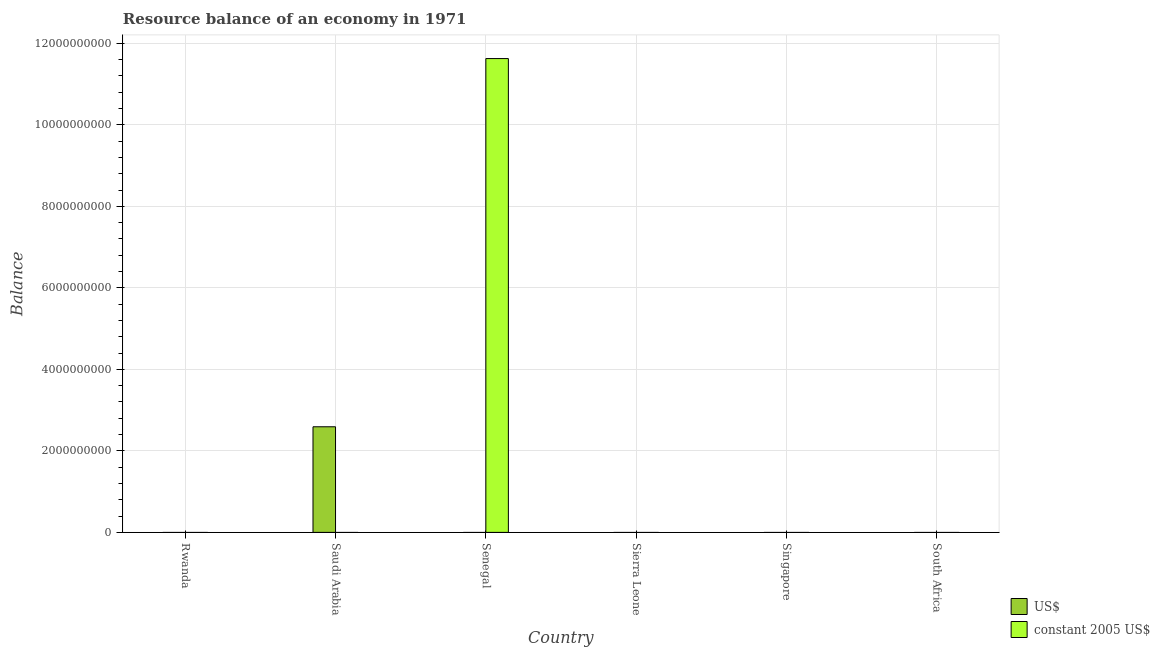How many different coloured bars are there?
Ensure brevity in your answer.  2. Are the number of bars on each tick of the X-axis equal?
Offer a terse response. No. How many bars are there on the 2nd tick from the left?
Your answer should be very brief. 1. How many bars are there on the 4th tick from the right?
Your answer should be compact. 1. What is the label of the 6th group of bars from the left?
Offer a very short reply. South Africa. In how many cases, is the number of bars for a given country not equal to the number of legend labels?
Keep it short and to the point. 6. What is the resource balance in constant us$ in Senegal?
Offer a very short reply. 1.16e+1. Across all countries, what is the maximum resource balance in us$?
Offer a terse response. 2.59e+09. Across all countries, what is the minimum resource balance in us$?
Offer a terse response. 0. In which country was the resource balance in us$ maximum?
Provide a short and direct response. Saudi Arabia. What is the total resource balance in us$ in the graph?
Give a very brief answer. 2.59e+09. What is the average resource balance in constant us$ per country?
Offer a terse response. 1.94e+09. What is the difference between the highest and the lowest resource balance in us$?
Make the answer very short. 2.59e+09. How many bars are there?
Offer a very short reply. 2. What is the difference between two consecutive major ticks on the Y-axis?
Ensure brevity in your answer.  2.00e+09. Are the values on the major ticks of Y-axis written in scientific E-notation?
Provide a succinct answer. No. Does the graph contain any zero values?
Offer a terse response. Yes. How are the legend labels stacked?
Offer a very short reply. Vertical. What is the title of the graph?
Ensure brevity in your answer.  Resource balance of an economy in 1971. What is the label or title of the X-axis?
Give a very brief answer. Country. What is the label or title of the Y-axis?
Provide a short and direct response. Balance. What is the Balance in US$ in Rwanda?
Your answer should be compact. 0. What is the Balance in US$ in Saudi Arabia?
Provide a short and direct response. 2.59e+09. What is the Balance in constant 2005 US$ in Saudi Arabia?
Your response must be concise. 0. What is the Balance in constant 2005 US$ in Senegal?
Give a very brief answer. 1.16e+1. Across all countries, what is the maximum Balance of US$?
Make the answer very short. 2.59e+09. Across all countries, what is the maximum Balance of constant 2005 US$?
Ensure brevity in your answer.  1.16e+1. Across all countries, what is the minimum Balance in US$?
Keep it short and to the point. 0. Across all countries, what is the minimum Balance in constant 2005 US$?
Ensure brevity in your answer.  0. What is the total Balance in US$ in the graph?
Your response must be concise. 2.59e+09. What is the total Balance of constant 2005 US$ in the graph?
Provide a short and direct response. 1.16e+1. What is the difference between the Balance in US$ in Saudi Arabia and the Balance in constant 2005 US$ in Senegal?
Your answer should be compact. -9.04e+09. What is the average Balance in US$ per country?
Provide a short and direct response. 4.32e+08. What is the average Balance of constant 2005 US$ per country?
Provide a short and direct response. 1.94e+09. What is the difference between the highest and the lowest Balance of US$?
Provide a succinct answer. 2.59e+09. What is the difference between the highest and the lowest Balance of constant 2005 US$?
Keep it short and to the point. 1.16e+1. 